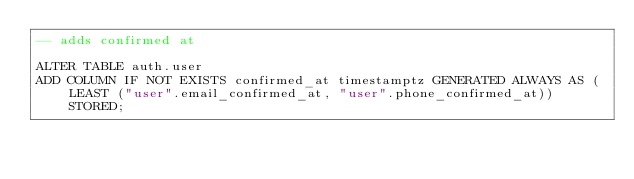<code> <loc_0><loc_0><loc_500><loc_500><_SQL_>-- adds confirmed at

ALTER TABLE auth.user
ADD COLUMN IF NOT EXISTS confirmed_at timestamptz GENERATED ALWAYS AS (LEAST ("user".email_confirmed_at, "user".phone_confirmed_at)) STORED;
</code> 